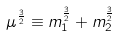Convert formula to latex. <formula><loc_0><loc_0><loc_500><loc_500>\mu ^ { \frac { 3 } { 2 } } \equiv m _ { 1 } ^ { \frac { 3 } { 2 } } + m _ { 2 } ^ { \frac { 3 } { 2 } }</formula> 